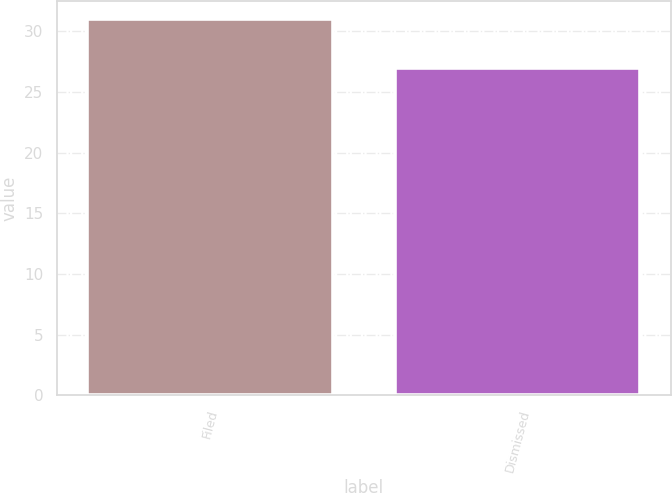Convert chart to OTSL. <chart><loc_0><loc_0><loc_500><loc_500><bar_chart><fcel>Filed<fcel>Dismissed<nl><fcel>31<fcel>27<nl></chart> 